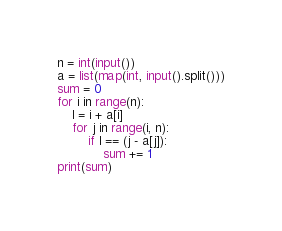<code> <loc_0><loc_0><loc_500><loc_500><_Python_>n = int(input())
a = list(map(int, input().split()))
sum = 0
for i in range(n):
    l = i + a[i]
    for j in range(i, n):
        if l == (j - a[j]):
            sum += 1
print(sum)</code> 